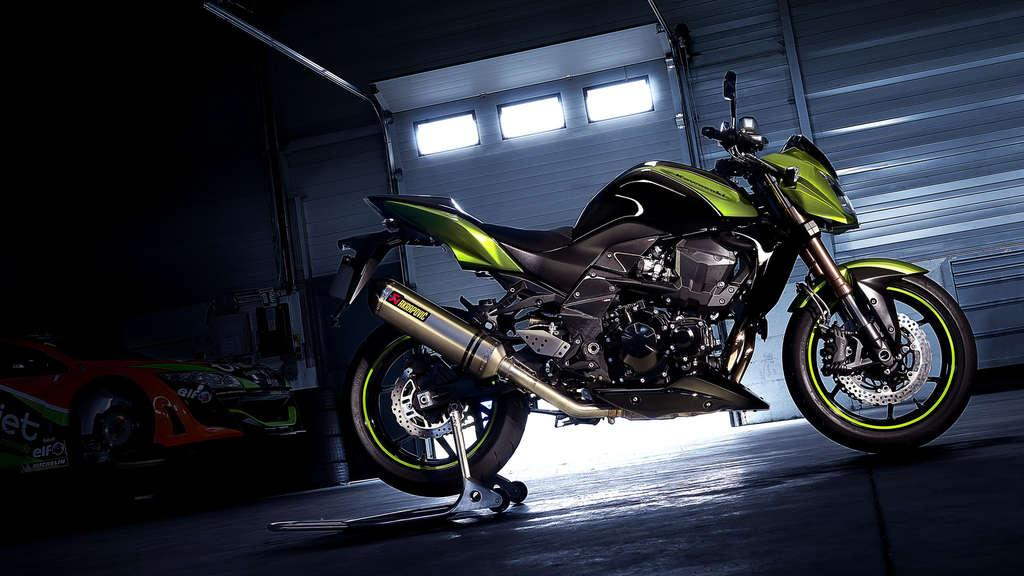What type of vehicle is in the middle of the image? There is a green and black color vehicle in the middle of the image. What can be seen on the left side of the image? There is a car on the left side of the image. Can you describe the shutter in the image? There is a shutter at the back of the image. What type of tiger can be seen playing with a toothbrush in the image? There is no tiger or toothbrush present in the image. How does the acoustics of the car on the left side of the image affect the sound quality? The provided facts do not mention anything about the acoustics of the car, so it cannot be determined from the image. 